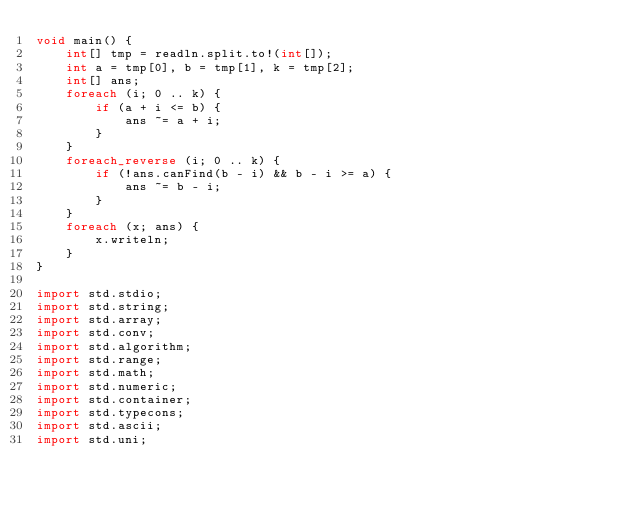Convert code to text. <code><loc_0><loc_0><loc_500><loc_500><_D_>void main() {
    int[] tmp = readln.split.to!(int[]);
    int a = tmp[0], b = tmp[1], k = tmp[2];
    int[] ans;
    foreach (i; 0 .. k) {
        if (a + i <= b) {
            ans ~= a + i;
        }
    }
    foreach_reverse (i; 0 .. k) {
        if (!ans.canFind(b - i) && b - i >= a) {
            ans ~= b - i;
        }
    }
    foreach (x; ans) {
        x.writeln;
    }
}

import std.stdio;
import std.string;
import std.array;
import std.conv;
import std.algorithm;
import std.range;
import std.math;
import std.numeric;
import std.container;
import std.typecons;
import std.ascii;
import std.uni;</code> 